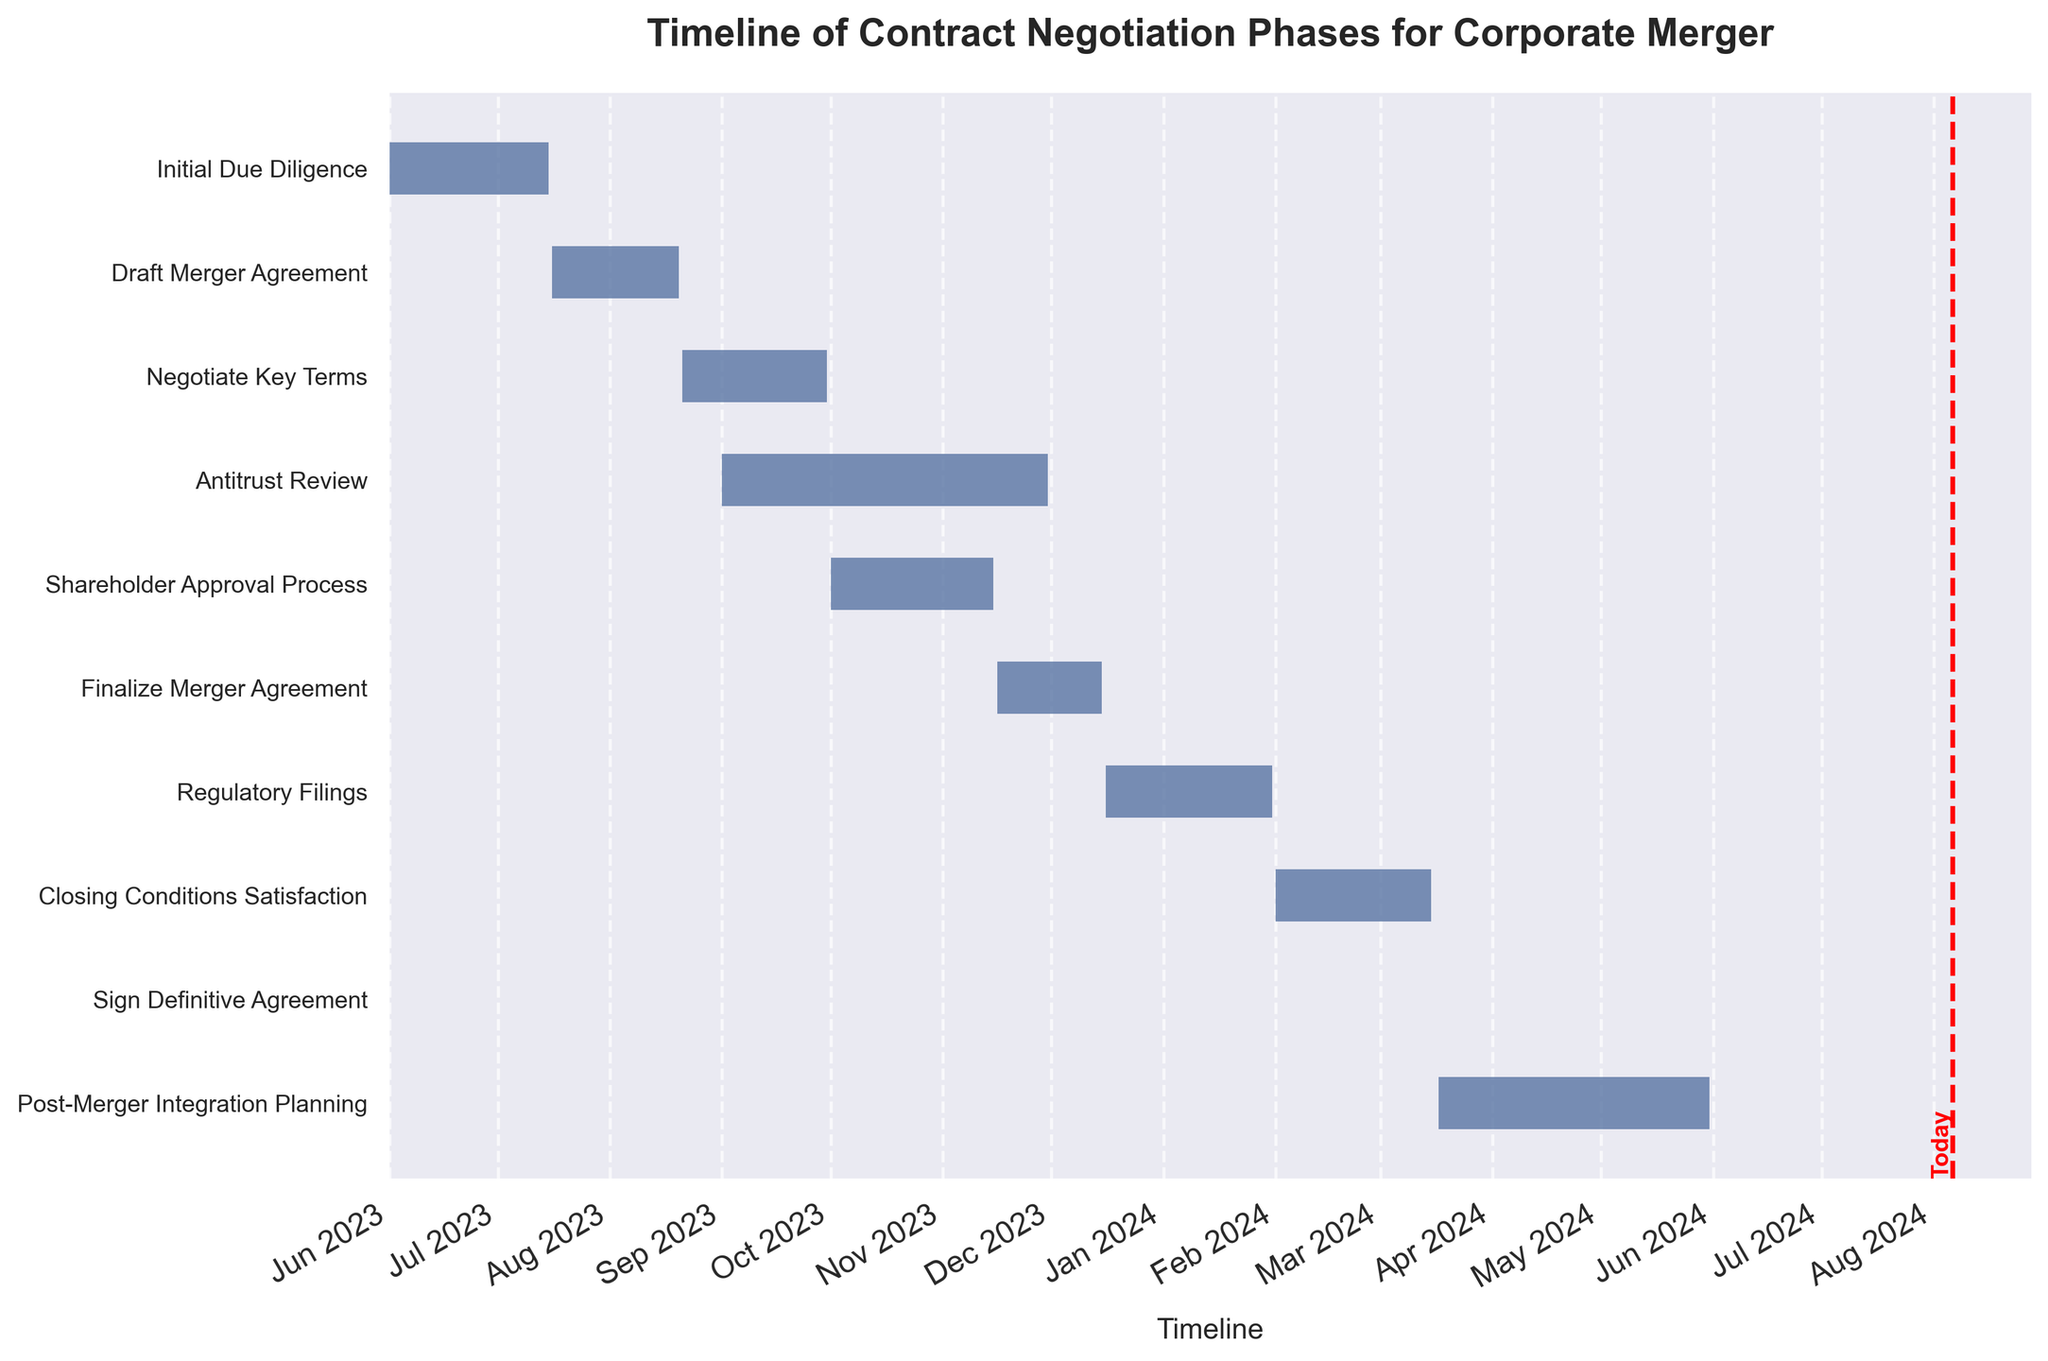What is the title of the chart? The title is usually found at the top of the chart. In this case, it is designed to situate the timeline within the context of contract negotiation phases for a corporate merger.
Answer: Timeline of Contract Negotiation Phases for Corporate Merger How many individual tasks are represented in the Gantt chart? By counting the number of horizontal bars or labels on the y-axis, we can determine the number of tasks represented.
Answer: 10 When does the "Draft Merger Agreement" phase start and end? Look at the horizontal bar corresponding to the "Draft Merger Agreement" task and note the dates on the time axis for the start and end of this bar.
Answer: Starts on 2023-07-16, ends on 2023-08-20 Which tasks are ongoing during October 2023? Identify the tasks with horizontal bars that overlap with the October 2023 section on the x-axis by following the task bars across the timeline.
Answer: Antitrust Review, Shareholder Approval Process What is the duration of the "Regulatory Filings" phase? Calculate the number of days between the start and end dates of the "Regulatory Filings" phase by referring to the length of its horizontal bar.
Answer: 47 days Which phase is the longest in duration? Compare the lengths of all the horizontal bars to identify the one that stretches the longest from start to end date.
Answer: Antitrust Review When did or will the "Post-Merger Integration Planning" start and end? Look at the horizontal bar labeled "Post-Merger Integration Planning" and note the dates for the start and end on the time axis.
Answer: Starts on 2024-03-17, ends on 2024-05-31 What significant milestone occurs on 2024-03-16? Identify the task or milestone that aligns with the date 2024-03-16 on the chart.
Answer: Sign Definitive Agreement How many tasks have overlapping durations with "Negotiate Key Terms"? Count the number of bars that overlap with the time span of "Negotiate Key Terms" (2023-08-21 to 2023-09-30) by checking the temporal alignment.
Answer: 1 (Antitrust Review) Which task has the shortest duration? Compare the lengths of all horizontal bars and identify the one with the shortest span from start to end date.
Answer: Sign Definitive Agreement 